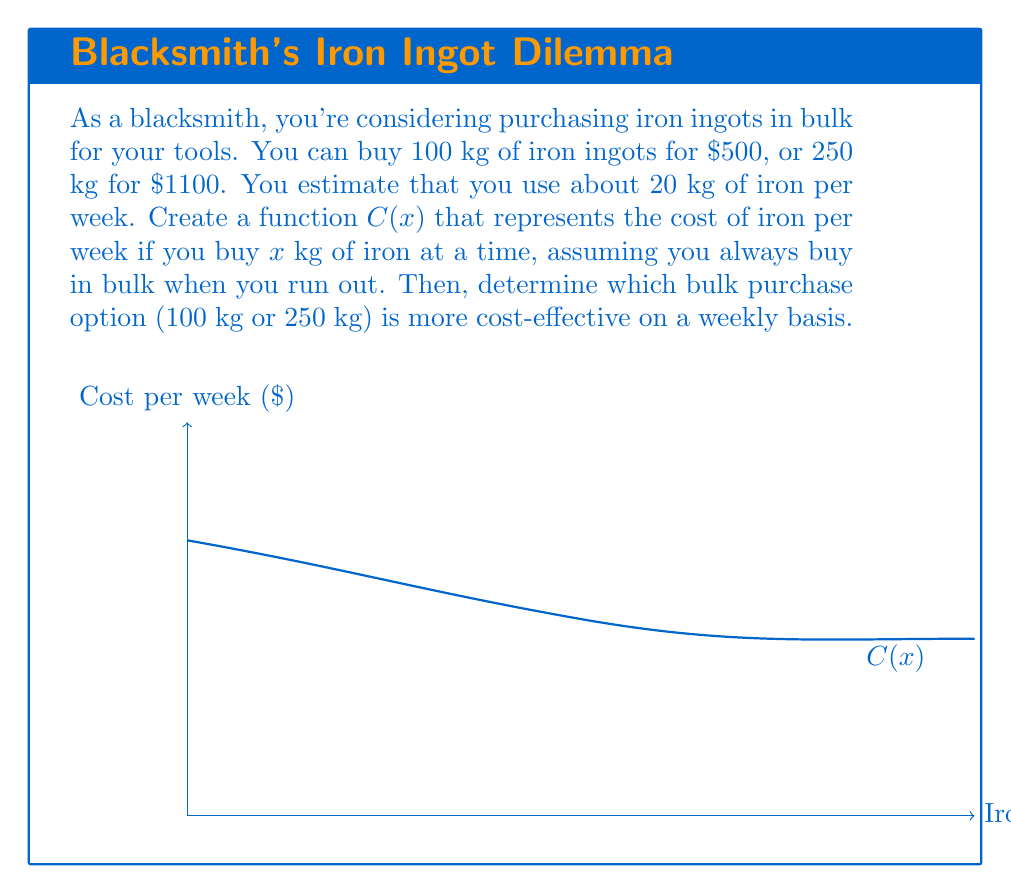Can you answer this question? Let's approach this step-by-step:

1) First, we need to create the cost function $C(x)$. The function should represent the weekly cost, so we need to divide the total cost by the number of weeks the purchase lasts.

2) For $x$ kg of iron:
   - Cost = $5x$ (based on the 100 kg for $500 price)
   - Number of weeks it lasts = $\frac{x}{20}$ (since 20 kg is used per week)

3) Therefore, the cost function is:

   $$C(x) = \frac{5x}{\frac{x}{20}} = \frac{100}{x}$$

4) Now, let's calculate the weekly cost for each option:

   For 100 kg: $C(100) = \frac{100}{100} = $1 per week
   
   For 250 kg: $C(250) = \frac{100}{250} = $0.40 per week

5) However, we need to check if the 250 kg option actually follows the $5 per kg rate:

   250 kg for $1100 is equivalent to $4.40 per kg, which is cheaper.

6) So, we need to recalculate $C(250)$ using the actual price:

   $C(250) = \frac{1100}{\frac{250}{20}} = \frac{1100}{12.5} = $88 per week

7) Comparing the two options:
   100 kg option: $100 per week
   250 kg option: $88 per week
Answer: The 250 kg bulk purchase at $1100 is more cost-effective, saving $12 per week. 